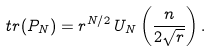Convert formula to latex. <formula><loc_0><loc_0><loc_500><loc_500>t r ( P _ { N } ) = r ^ { N / 2 } \, U _ { N } \left ( \frac { n } { 2 \sqrt { r } } \right ) .</formula> 